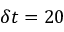<formula> <loc_0><loc_0><loc_500><loc_500>\delta t = 2 0</formula> 